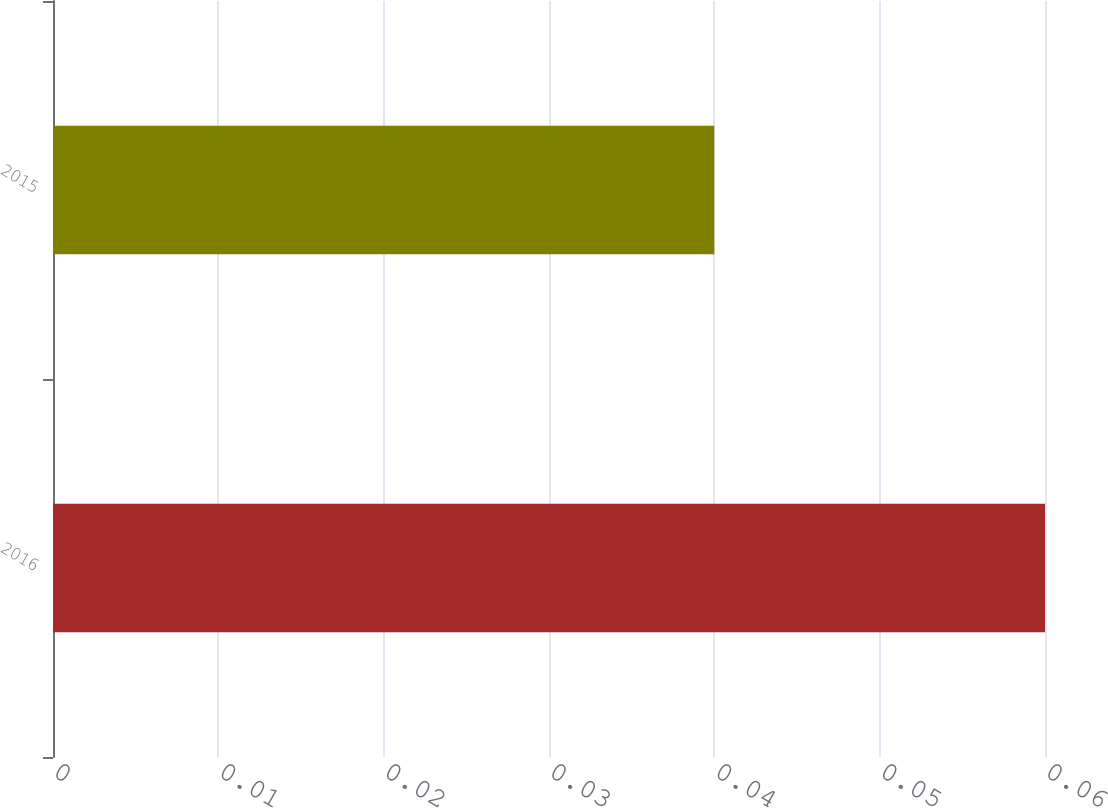<chart> <loc_0><loc_0><loc_500><loc_500><bar_chart><fcel>2016<fcel>2015<nl><fcel>0.06<fcel>0.04<nl></chart> 